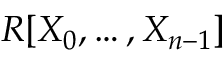Convert formula to latex. <formula><loc_0><loc_0><loc_500><loc_500>R [ X _ { 0 } , \dots c , X _ { n - 1 } ]</formula> 